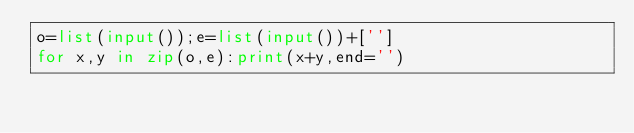<code> <loc_0><loc_0><loc_500><loc_500><_Python_>o=list(input());e=list(input())+['']
for x,y in zip(o,e):print(x+y,end='')</code> 